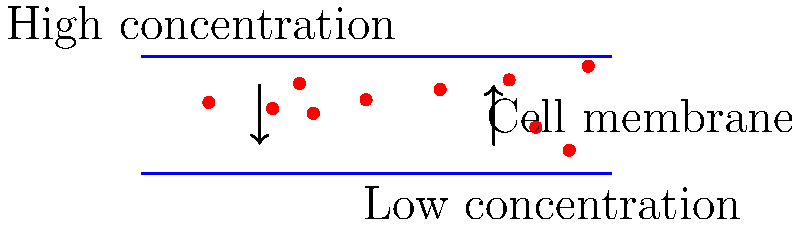En el desarrollo de su terapia revolucionaria, usted está estudiando la difusión de partículas a través de una membrana celular. Si la concentración inicial de partículas en el lado izquierdo de la membrana es el doble que en el lado derecho, y el coeficiente de difusión es $D = 5 \times 10^{-6} \text{ cm}^2/\text{s}$, ¿cuál es el flujo de partículas (en partículas/$\text{cm}^2\cdot\text{s}$) a través de la membrana si el gradiente de concentración es de 1000 partículas/$\text{cm}^3$ por micrómetro? Para resolver este problema, seguiremos estos pasos:

1) La primera ley de Fick describe el flujo de partículas debido a la difusión:

   $$J = -D \frac{dC}{dx}$$

   Donde:
   $J$ es el flujo de partículas
   $D$ es el coeficiente de difusión
   $\frac{dC}{dx}$ es el gradiente de concentración

2) Nos dan el coeficiente de difusión $D = 5 \times 10^{-6} \text{ cm}^2/\text{s}$

3) El gradiente de concentración es 1000 partículas/$\text{cm}^3$ por micrómetro.
   Convertimos esto a unidades consistentes:
   1 μm = $10^{-4}$ cm
   Entonces, el gradiente es:
   1000 partículas/$\text{cm}^3$ por $10^{-4}$ cm = $10^7$ partículas/$\text{cm}^4$

4) Sustituyendo en la ecuación de Fick:

   $$J = -(5 \times 10^{-6} \text{ cm}^2/\text{s})(10^7 \text{ partículas}/\text{cm}^4)$$

5) Calculamos:

   $$J = -5 \times 10^1 \text{ partículas}/(\text{cm}^2 \cdot \text{s})$$

6) El signo negativo indica que el flujo va de mayor a menor concentración, pero generalmente se reporta la magnitud del flujo.
Answer: $5 \times 10^1 \text{ partículas}/(\text{cm}^2 \cdot \text{s})$ 